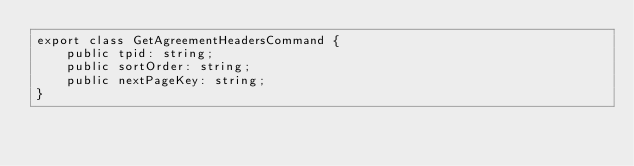Convert code to text. <code><loc_0><loc_0><loc_500><loc_500><_TypeScript_>export class GetAgreementHeadersCommand {
    public tpid: string;
    public sortOrder: string;
    public nextPageKey: string;
}</code> 